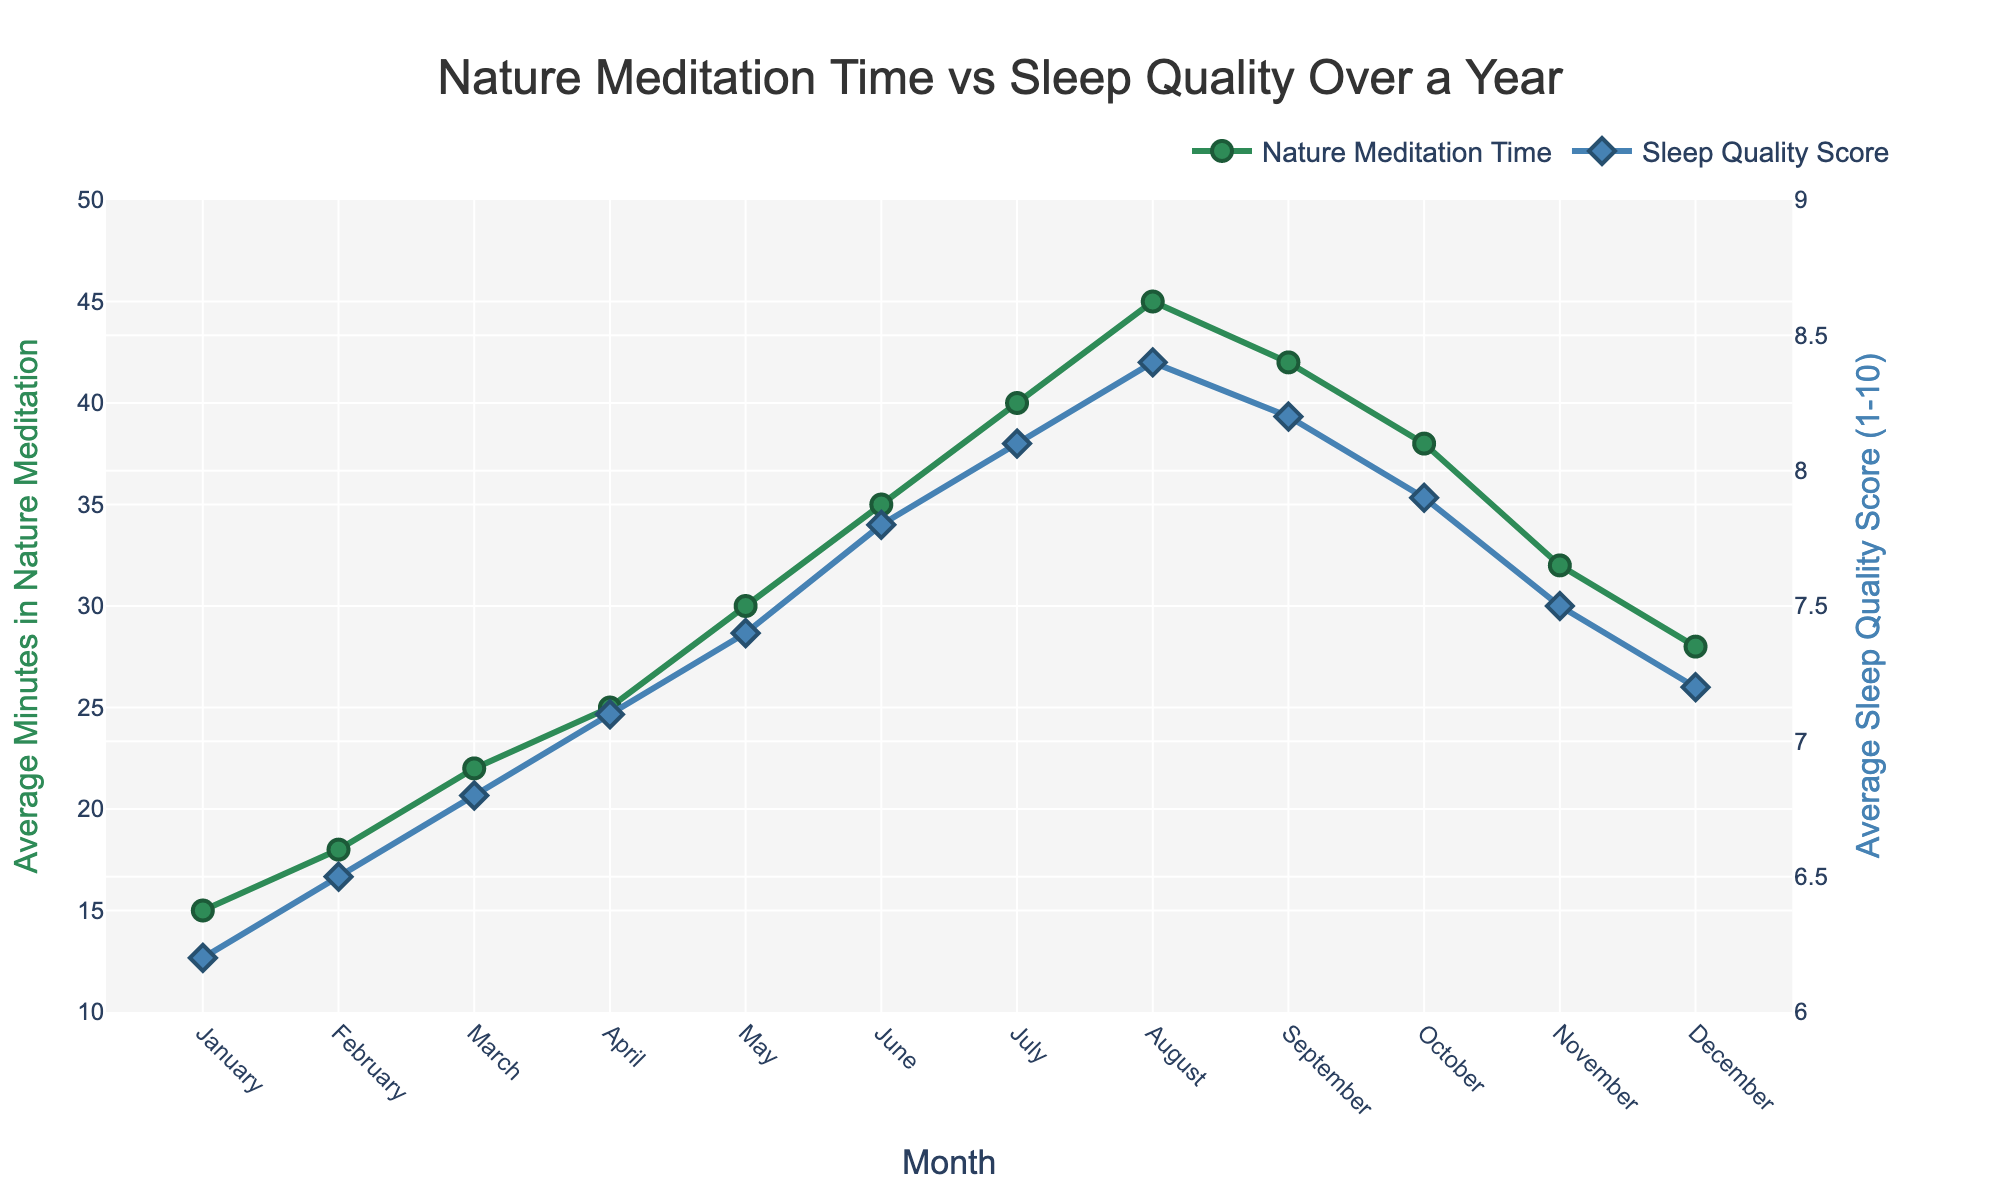How does the sleep quality score change from January to July? The sleep quality score starts at 6.2 in January and gradually increases month by month, reaching 8.1 in July.
Answer: It increases from 6.2 to 8.1 Which month shows the highest average minutes spent in nature meditation, and what is the corresponding sleep quality score? August shows the highest average minutes spent in nature meditation at 45 minutes. The corresponding sleep quality score for August is 8.4.
Answer: August, 8.4 Compare the sleep quality scores between June and December. Which is higher and by how much? The sleep quality score in June is 7.8, whereas in December it is 7.2. Therefore, the score in June is higher by 0.6.
Answer: June is higher by 0.6 What is the percentage increase in nature meditation time from January to June? The nature meditation time in January is 15 minutes, and in June it is 35 minutes. The percentage increase is calculated as ((35 - 15) / 15) * 100 = 133.33%.
Answer: 133.33% By how much does the average sleep quality score change from the lowest to the highest month? The lowest sleep quality score is in January at 6.2, and the highest is in August at 8.4. The difference is 8.4 - 6.2 = 2.2.
Answer: 2.2 Which month has the smallest gap between nature meditation time and sleep quality score and what is the difference? December has the smallest gap. The average minutes in nature meditation is 28 and the sleep quality score is 7.2. The difference is 28 - 7.2 = 20.8.
Answer: December, 20.8 What trend do you observe between nature-based meditation time and sleep quality score from April to October? From April to August, both the meditation time and sleep quality score increase. They peak in August and then start to decrease from September to October.
Answer: Increase then decrease Compare nature meditation time in May and November. Which month has more minutes and by how much? In May, the nature meditation time is 30 minutes, and in November, it is 32 minutes. November has 2 minutes more than May.
Answer: November, by 2 minutes What is the average sleep quality score for the first half of the year? The sleep quality scores for the first six months (January to June) are 6.2, 6.5, 6.8, 7.1, 7.4, and 7.8. The average is (6.2 + 6.5 + 6.8 + 7.1 + 7.4 + 7.8) / 6 = 6.97.
Answer: 6.97 